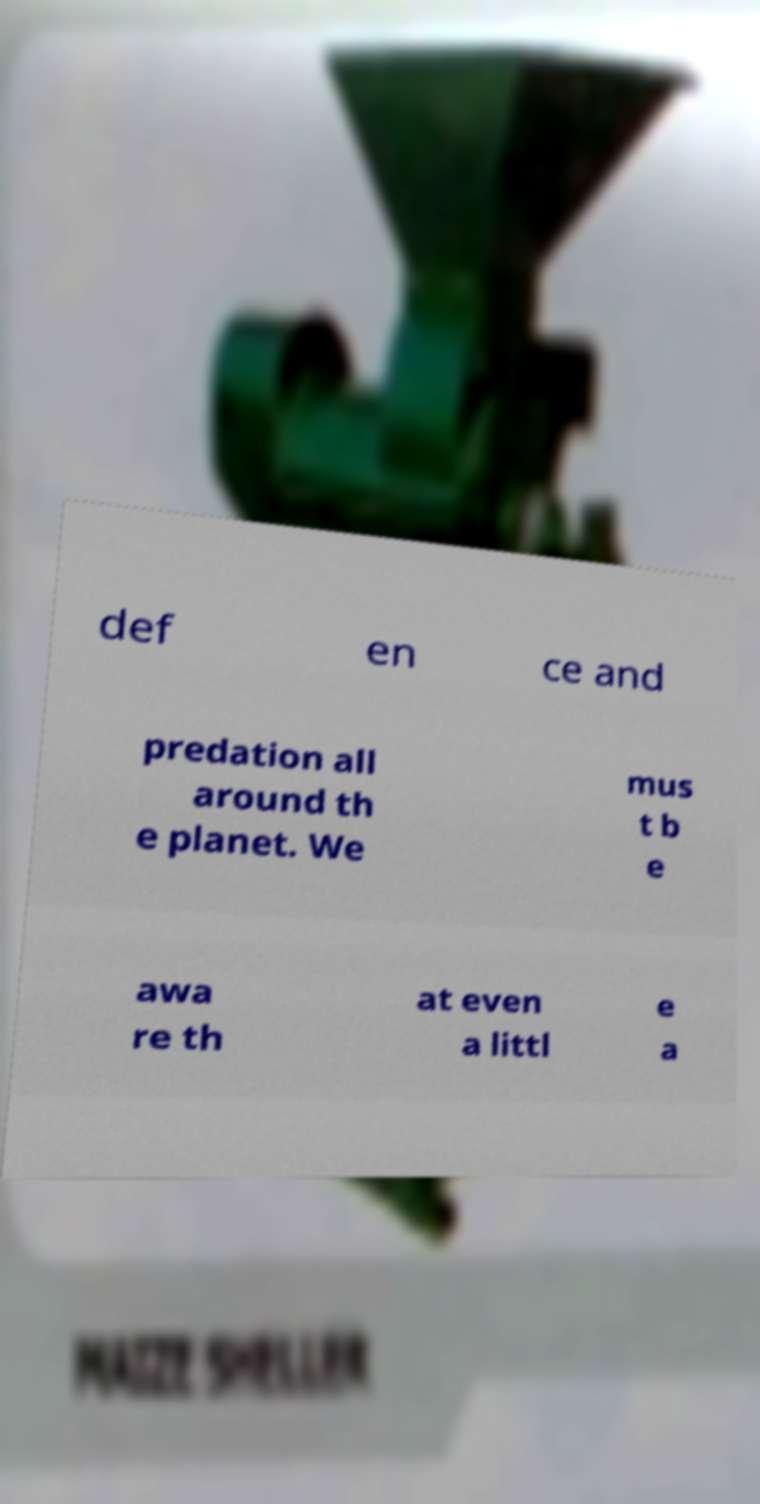For documentation purposes, I need the text within this image transcribed. Could you provide that? def en ce and predation all around th e planet. We mus t b e awa re th at even a littl e a 